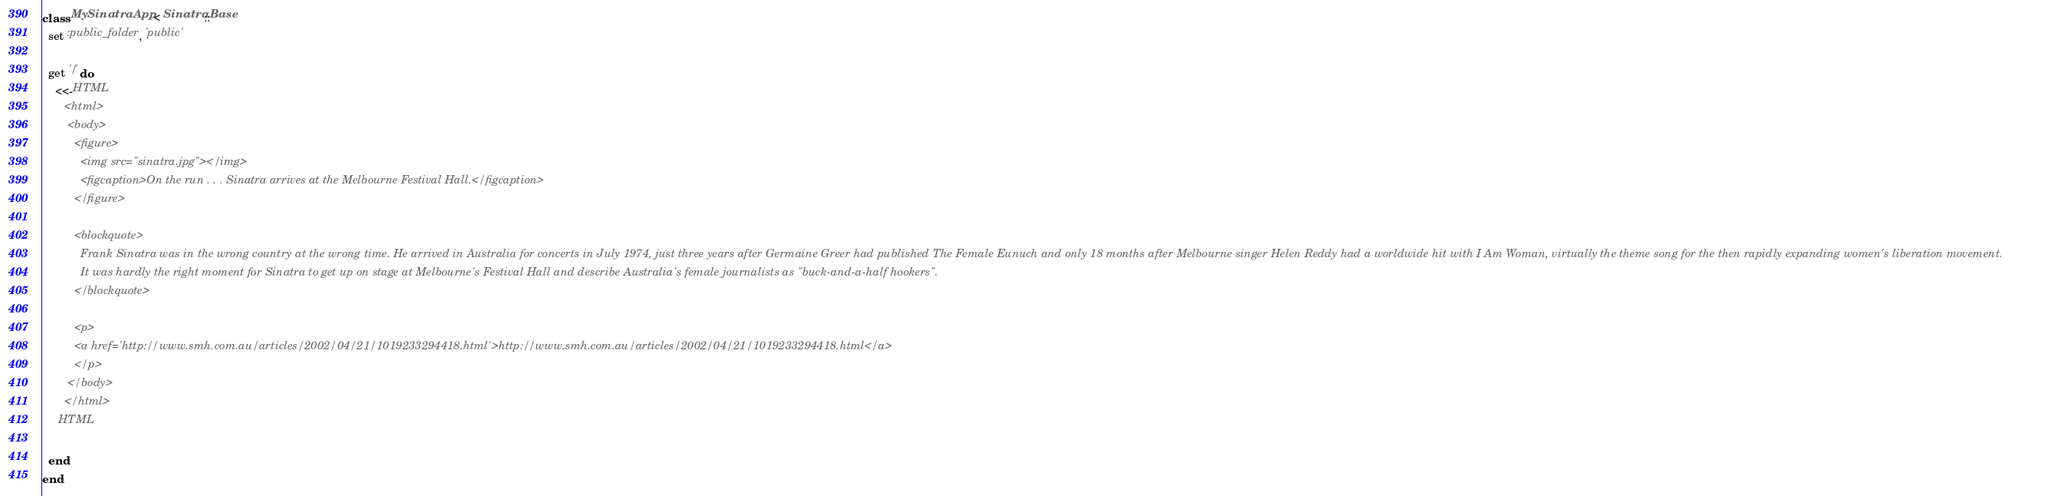Convert code to text. <code><loc_0><loc_0><loc_500><loc_500><_Ruby_>class MySinatraApp < Sinatra::Base
  set :public_folder, 'public'

  get '/' do
    <<-HTML
       <html>
        <body>
          <figure>
            <img src="sinatra.jpg"></img>
            <figcaption>On the run . . . Sinatra arrives at the Melbourne Festival Hall.</figcaption>
          </figure>

          <blockquote>
            Frank Sinatra was in the wrong country at the wrong time. He arrived in Australia for concerts in July 1974, just three years after Germaine Greer had published The Female Eunuch and only 18 months after Melbourne singer Helen Reddy had a worldwide hit with I Am Woman, virtually the theme song for the then rapidly expanding women's liberation movement.
            It was hardly the right moment for Sinatra to get up on stage at Melbourne's Festival Hall and describe Australia's female journalists as "buck-and-a-half hookers".
          </blockquote>

          <p>
          <a href='http://www.smh.com.au/articles/2002/04/21/1019233294418.html'>http://www.smh.com.au/articles/2002/04/21/1019233294418.html</a>
          </p>
        </body>
       </html>
     HTML

  end
end
</code> 